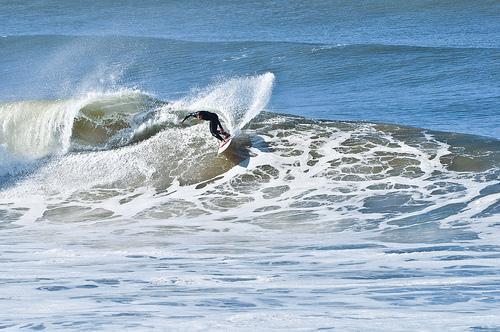How many people are visibly surfing?
Give a very brief answer. 1. 